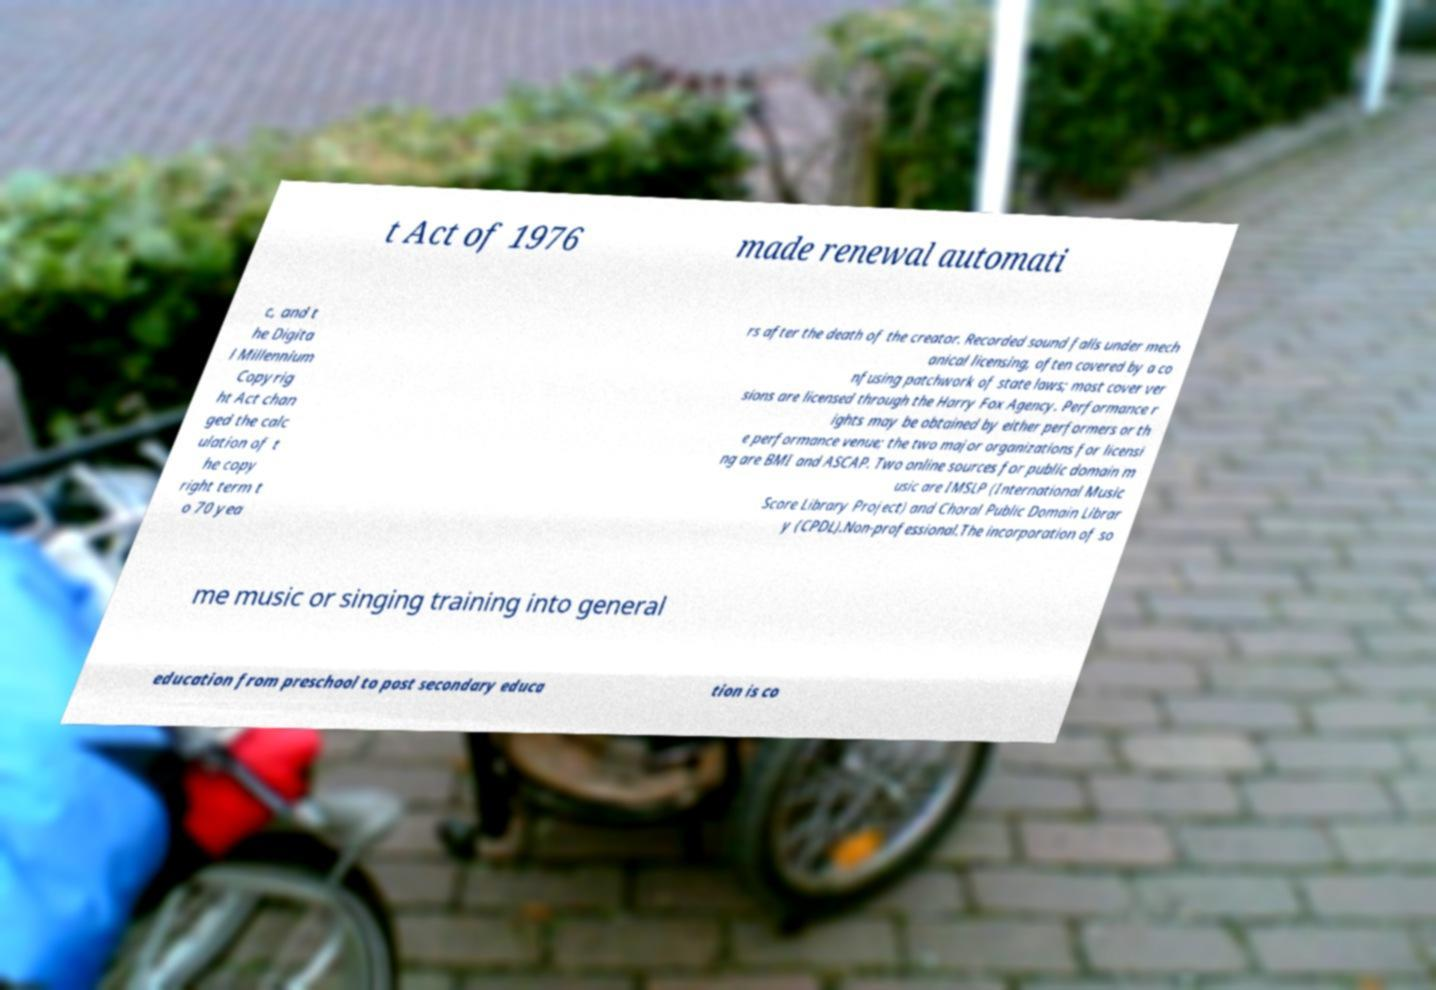Could you assist in decoding the text presented in this image and type it out clearly? t Act of 1976 made renewal automati c, and t he Digita l Millennium Copyrig ht Act chan ged the calc ulation of t he copy right term t o 70 yea rs after the death of the creator. Recorded sound falls under mech anical licensing, often covered by a co nfusing patchwork of state laws; most cover ver sions are licensed through the Harry Fox Agency. Performance r ights may be obtained by either performers or th e performance venue; the two major organizations for licensi ng are BMI and ASCAP. Two online sources for public domain m usic are IMSLP (International Music Score Library Project) and Choral Public Domain Librar y (CPDL).Non-professional.The incorporation of so me music or singing training into general education from preschool to post secondary educa tion is co 